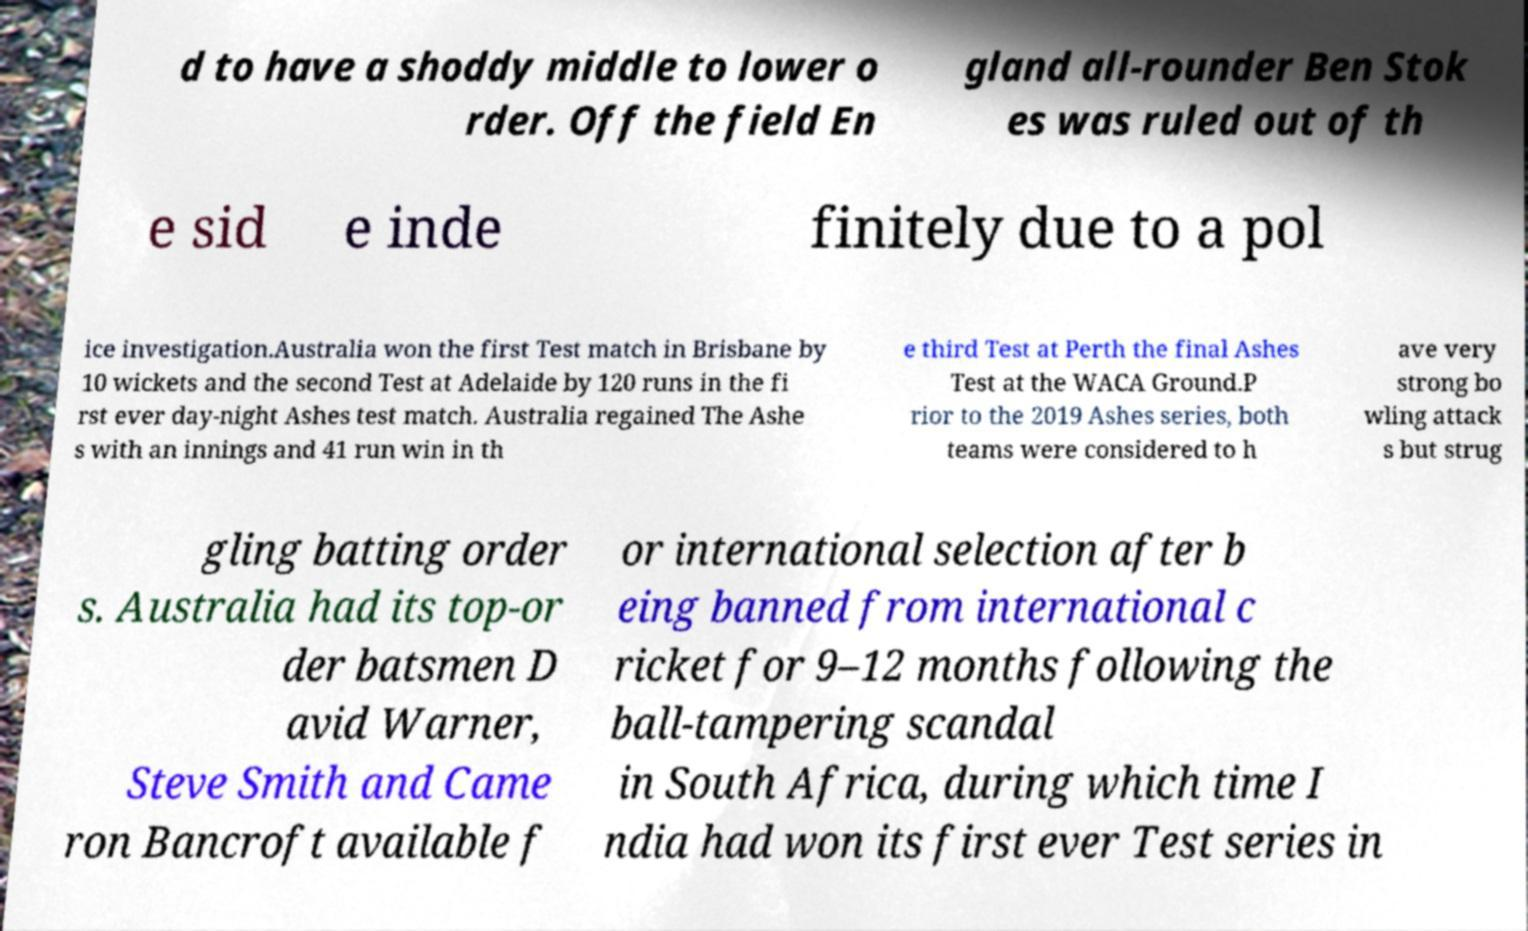Could you assist in decoding the text presented in this image and type it out clearly? d to have a shoddy middle to lower o rder. Off the field En gland all-rounder Ben Stok es was ruled out of th e sid e inde finitely due to a pol ice investigation.Australia won the first Test match in Brisbane by 10 wickets and the second Test at Adelaide by 120 runs in the fi rst ever day-night Ashes test match. Australia regained The Ashe s with an innings and 41 run win in th e third Test at Perth the final Ashes Test at the WACA Ground.P rior to the 2019 Ashes series, both teams were considered to h ave very strong bo wling attack s but strug gling batting order s. Australia had its top-or der batsmen D avid Warner, Steve Smith and Came ron Bancroft available f or international selection after b eing banned from international c ricket for 9–12 months following the ball-tampering scandal in South Africa, during which time I ndia had won its first ever Test series in 